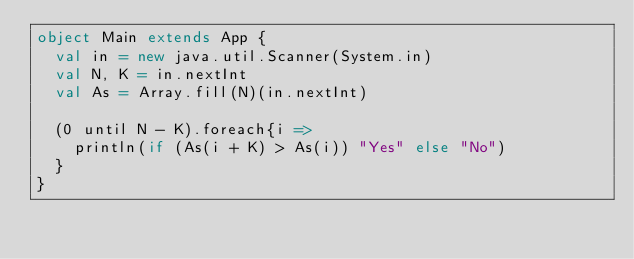Convert code to text. <code><loc_0><loc_0><loc_500><loc_500><_Scala_>object Main extends App {
  val in = new java.util.Scanner(System.in)
  val N, K = in.nextInt
  val As = Array.fill(N)(in.nextInt)

  (0 until N - K).foreach{i =>
    println(if (As(i + K) > As(i)) "Yes" else "No")
  }
}</code> 